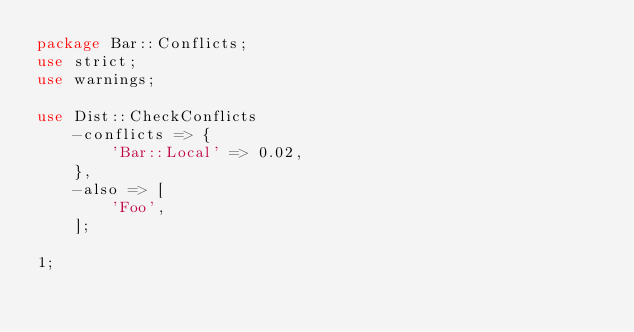Convert code to text. <code><loc_0><loc_0><loc_500><loc_500><_Perl_>package Bar::Conflicts;
use strict;
use warnings;

use Dist::CheckConflicts
    -conflicts => {
        'Bar::Local' => 0.02,
    },
    -also => [
        'Foo',
    ];

1;
</code> 